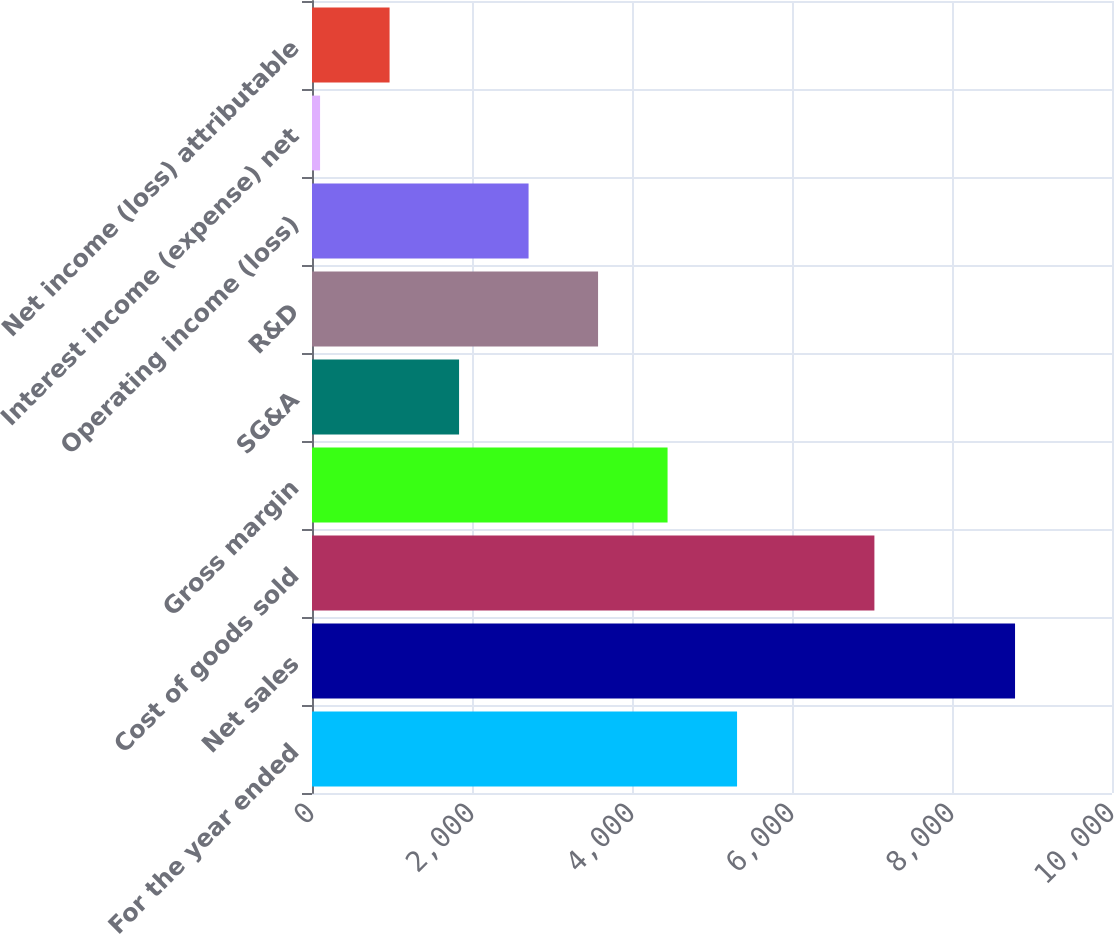Convert chart. <chart><loc_0><loc_0><loc_500><loc_500><bar_chart><fcel>For the year ended<fcel>Net sales<fcel>Cost of goods sold<fcel>Gross margin<fcel>SG&A<fcel>R&D<fcel>Operating income (loss)<fcel>Interest income (expense) net<fcel>Net income (loss) attributable<nl><fcel>5313.2<fcel>8788<fcel>7030<fcel>4444.5<fcel>1838.4<fcel>3575.8<fcel>2707.1<fcel>101<fcel>969.7<nl></chart> 